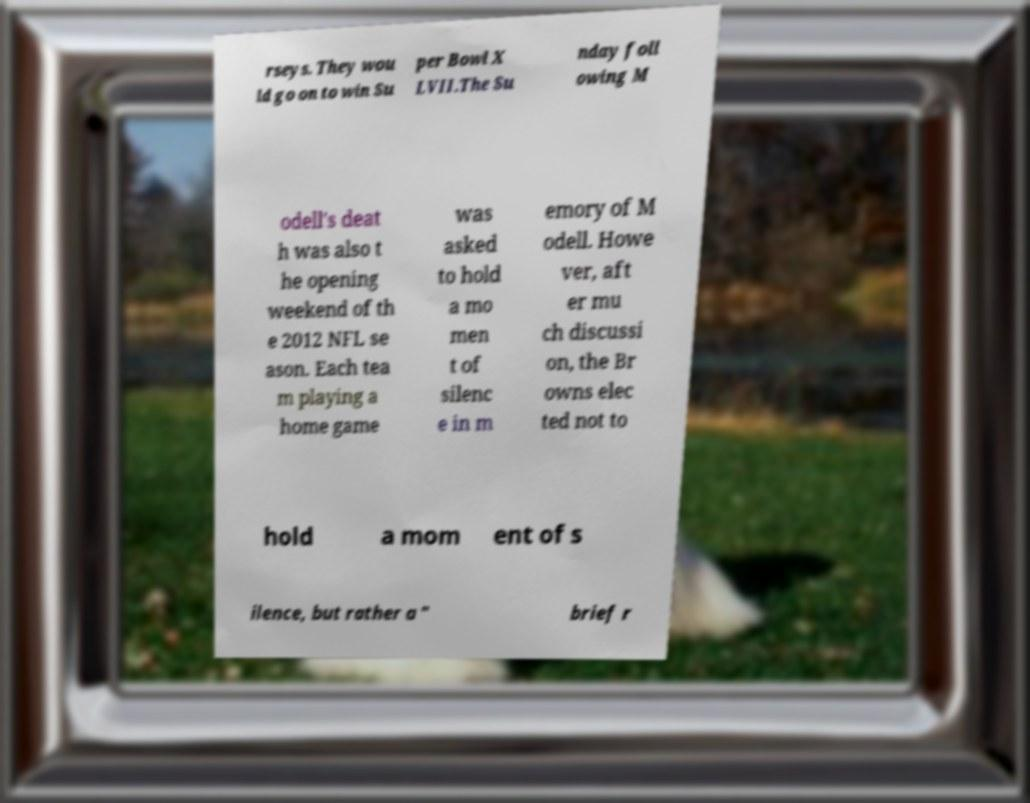Can you accurately transcribe the text from the provided image for me? rseys. They wou ld go on to win Su per Bowl X LVII.The Su nday foll owing M odell's deat h was also t he opening weekend of th e 2012 NFL se ason. Each tea m playing a home game was asked to hold a mo men t of silenc e in m emory of M odell. Howe ver, aft er mu ch discussi on, the Br owns elec ted not to hold a mom ent of s ilence, but rather a " brief r 